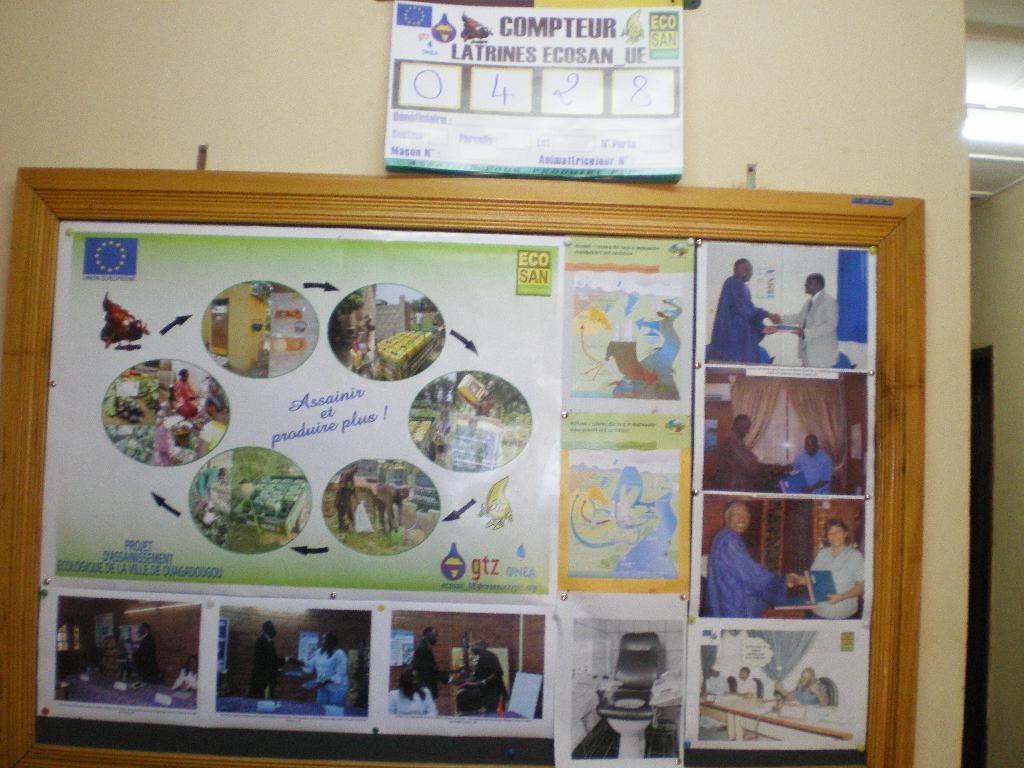What number is on the top poster?
Keep it short and to the point. 0428. 